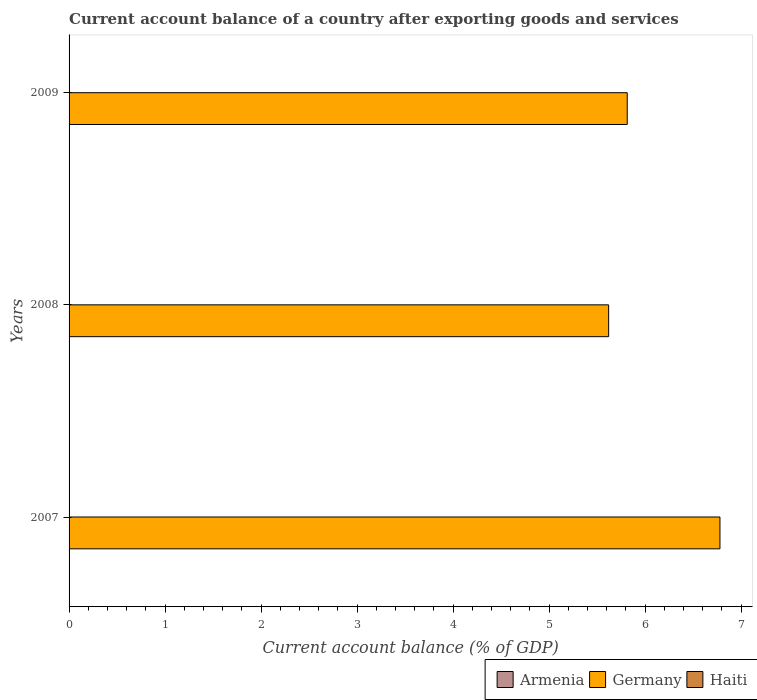How many different coloured bars are there?
Give a very brief answer. 1. Are the number of bars per tick equal to the number of legend labels?
Your answer should be compact. No. Are the number of bars on each tick of the Y-axis equal?
Keep it short and to the point. Yes. How many bars are there on the 1st tick from the bottom?
Your answer should be compact. 1. What is the label of the 1st group of bars from the top?
Your answer should be compact. 2009. In how many cases, is the number of bars for a given year not equal to the number of legend labels?
Your response must be concise. 3. What is the account balance in Germany in 2009?
Ensure brevity in your answer.  5.81. Across all years, what is the maximum account balance in Germany?
Your answer should be compact. 6.78. Across all years, what is the minimum account balance in Germany?
Provide a succinct answer. 5.62. What is the total account balance in Haiti in the graph?
Provide a short and direct response. 0. What is the difference between the account balance in Germany in 2007 and that in 2008?
Provide a short and direct response. 1.16. What is the difference between the account balance in Armenia in 2008 and the account balance in Germany in 2007?
Provide a short and direct response. -6.78. What is the average account balance in Germany per year?
Offer a terse response. 6.07. What is the ratio of the account balance in Germany in 2007 to that in 2009?
Provide a succinct answer. 1.17. Is the account balance in Germany in 2007 less than that in 2009?
Give a very brief answer. No. What is the difference between the highest and the lowest account balance in Germany?
Keep it short and to the point. 1.16. Is the sum of the account balance in Germany in 2007 and 2009 greater than the maximum account balance in Armenia across all years?
Your answer should be very brief. Yes. Are all the bars in the graph horizontal?
Offer a terse response. Yes. What is the difference between two consecutive major ticks on the X-axis?
Your answer should be compact. 1. Are the values on the major ticks of X-axis written in scientific E-notation?
Offer a terse response. No. Does the graph contain grids?
Make the answer very short. No. Where does the legend appear in the graph?
Give a very brief answer. Bottom right. What is the title of the graph?
Ensure brevity in your answer.  Current account balance of a country after exporting goods and services. Does "Costa Rica" appear as one of the legend labels in the graph?
Provide a short and direct response. No. What is the label or title of the X-axis?
Provide a short and direct response. Current account balance (% of GDP). What is the label or title of the Y-axis?
Your response must be concise. Years. What is the Current account balance (% of GDP) in Germany in 2007?
Keep it short and to the point. 6.78. What is the Current account balance (% of GDP) in Haiti in 2007?
Provide a short and direct response. 0. What is the Current account balance (% of GDP) in Armenia in 2008?
Provide a short and direct response. 0. What is the Current account balance (% of GDP) of Germany in 2008?
Provide a short and direct response. 5.62. What is the Current account balance (% of GDP) of Haiti in 2008?
Provide a succinct answer. 0. What is the Current account balance (% of GDP) in Germany in 2009?
Offer a terse response. 5.81. Across all years, what is the maximum Current account balance (% of GDP) in Germany?
Your response must be concise. 6.78. Across all years, what is the minimum Current account balance (% of GDP) in Germany?
Offer a terse response. 5.62. What is the total Current account balance (% of GDP) of Germany in the graph?
Make the answer very short. 18.21. What is the difference between the Current account balance (% of GDP) of Germany in 2007 and that in 2008?
Your answer should be compact. 1.16. What is the difference between the Current account balance (% of GDP) of Germany in 2007 and that in 2009?
Ensure brevity in your answer.  0.97. What is the difference between the Current account balance (% of GDP) in Germany in 2008 and that in 2009?
Provide a succinct answer. -0.19. What is the average Current account balance (% of GDP) of Armenia per year?
Provide a succinct answer. 0. What is the average Current account balance (% of GDP) in Germany per year?
Your answer should be very brief. 6.07. What is the ratio of the Current account balance (% of GDP) in Germany in 2007 to that in 2008?
Your answer should be compact. 1.21. What is the ratio of the Current account balance (% of GDP) of Germany in 2007 to that in 2009?
Your response must be concise. 1.17. What is the ratio of the Current account balance (% of GDP) in Germany in 2008 to that in 2009?
Your answer should be compact. 0.97. What is the difference between the highest and the second highest Current account balance (% of GDP) of Germany?
Keep it short and to the point. 0.97. What is the difference between the highest and the lowest Current account balance (% of GDP) in Germany?
Your answer should be compact. 1.16. 